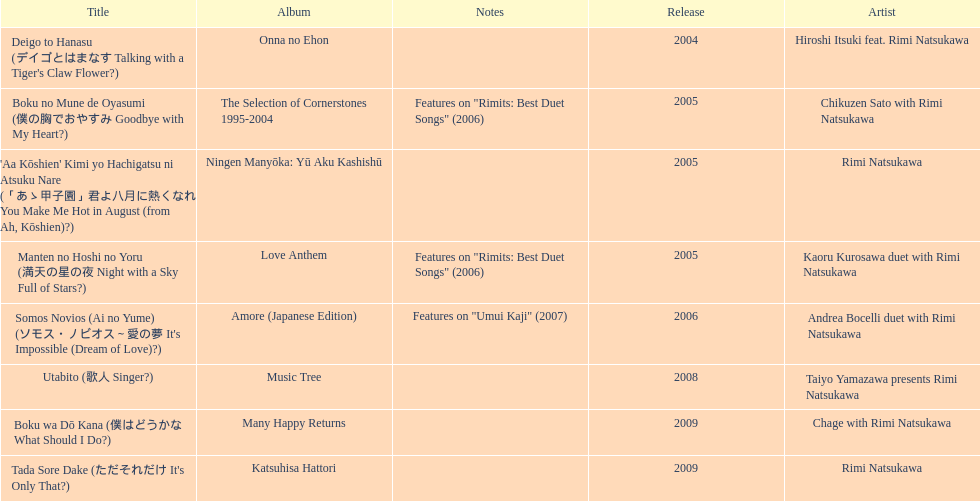What is the number of albums released with the artist rimi natsukawa? 8. 